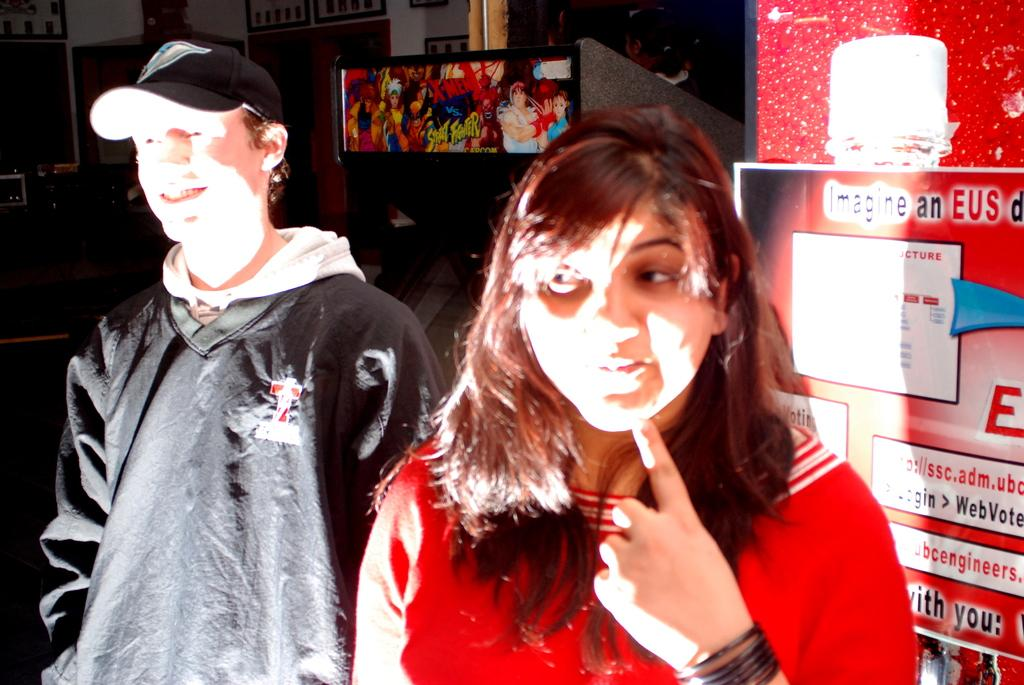How many people are in the image? There are two people in the image, a boy and a girl. What are the boy and girl doing in the image? The boy and girl are standing together. What is located behind the boy and girl? There is a screen behind the boy and girl. What can be seen on the wall in the image? There is a poster on the wall in the image. What suggestion does the boy make to the girl in the image? There is no conversation or suggestion visible in the image; it only shows the boy and girl standing together. 